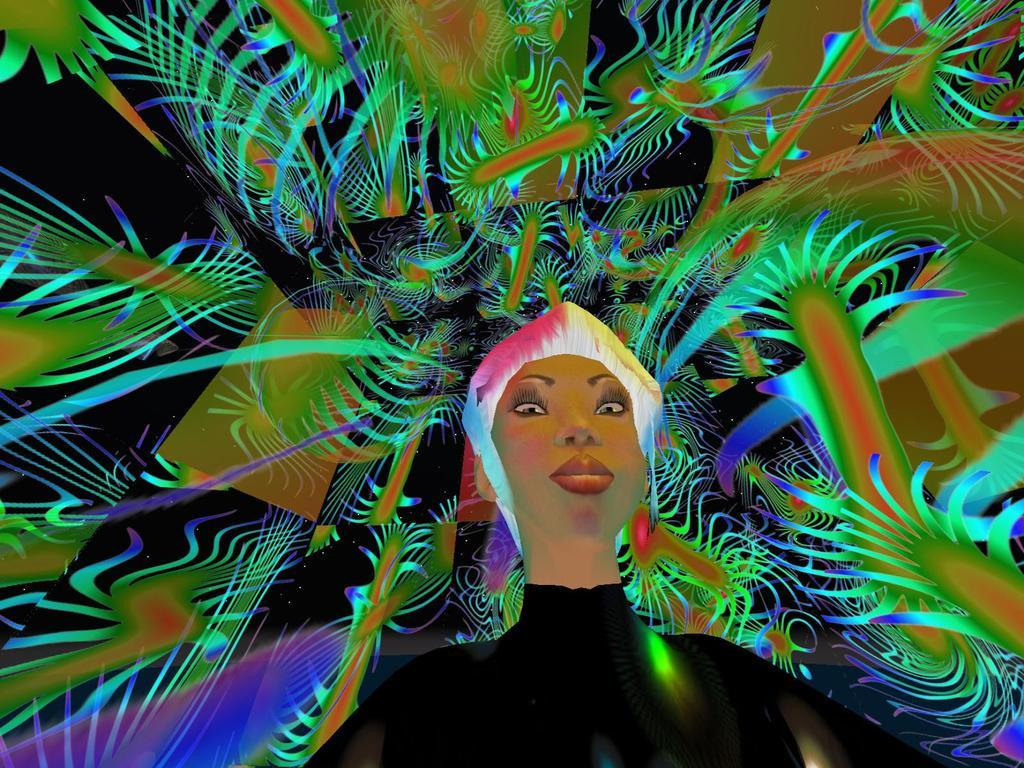Who is present in the image? There is a woman in the image. What is the woman wearing on her head? The woman is wearing a crown. What type of property does the woman own in the image? There is no information about property ownership in the image. What material is the vest made of that the woman is wearing in the image? The woman is not wearing a vest in the image. 